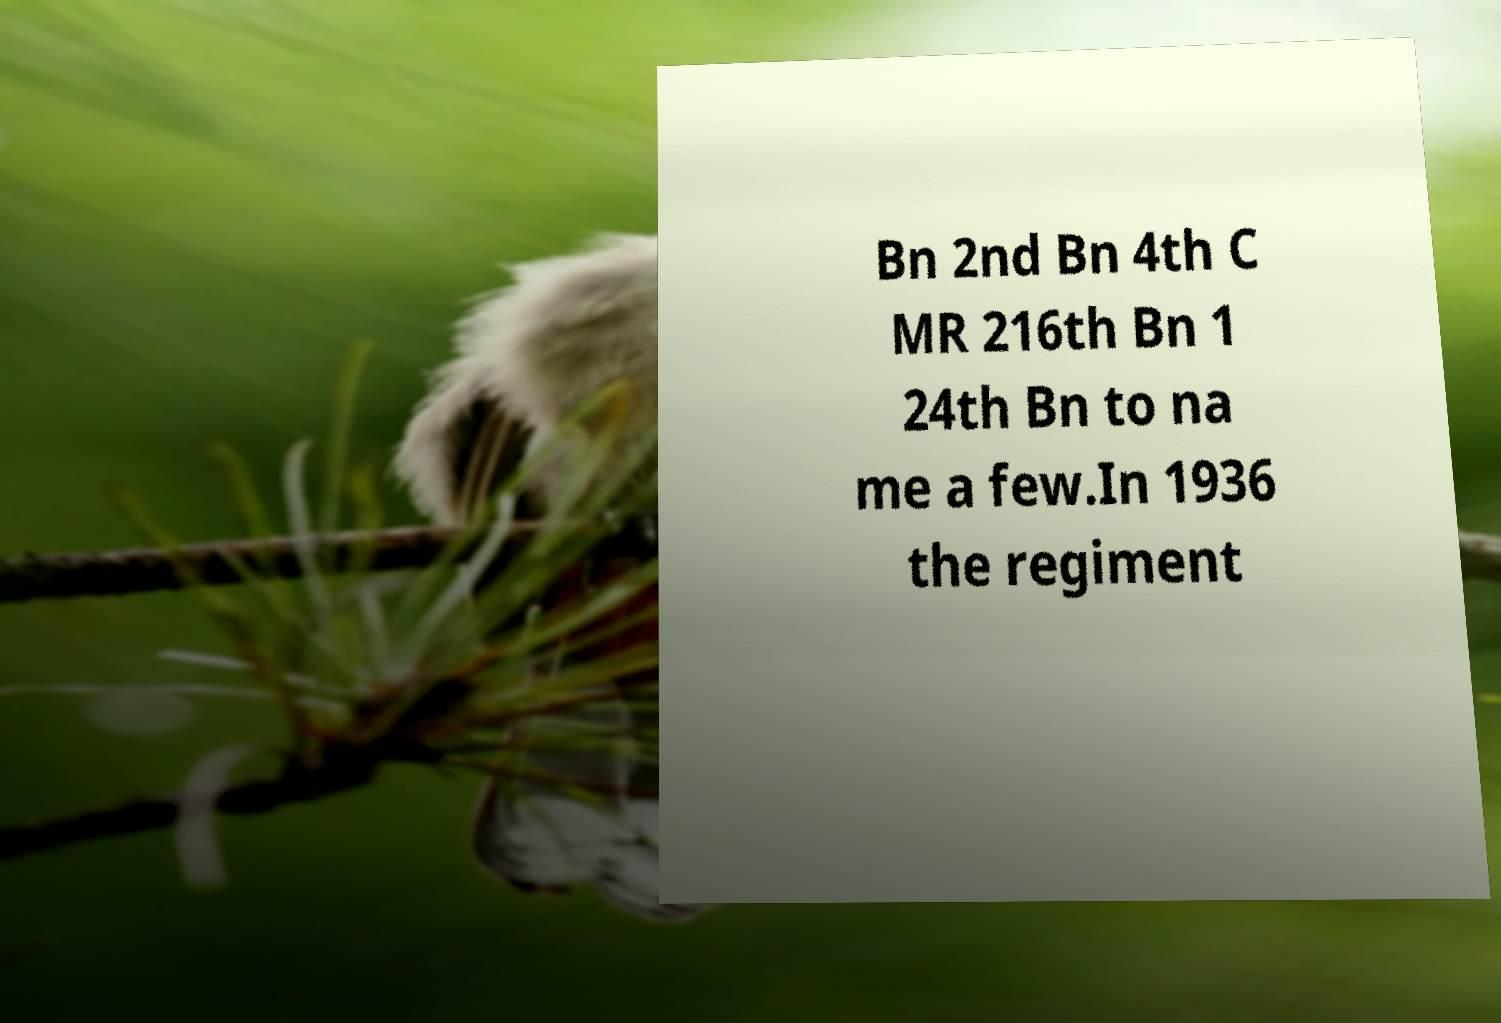I need the written content from this picture converted into text. Can you do that? Bn 2nd Bn 4th C MR 216th Bn 1 24th Bn to na me a few.In 1936 the regiment 